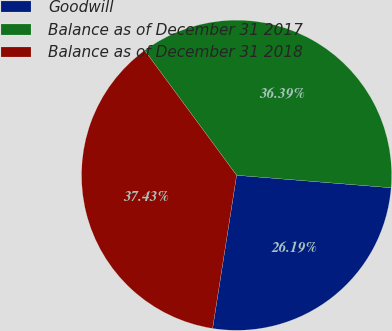Convert chart to OTSL. <chart><loc_0><loc_0><loc_500><loc_500><pie_chart><fcel>Goodwill<fcel>Balance as of December 31 2017<fcel>Balance as of December 31 2018<nl><fcel>26.19%<fcel>36.39%<fcel>37.43%<nl></chart> 